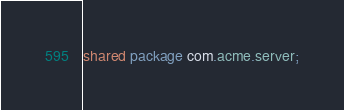Convert code to text. <code><loc_0><loc_0><loc_500><loc_500><_Ceylon_>shared package com.acme.server;
</code> 